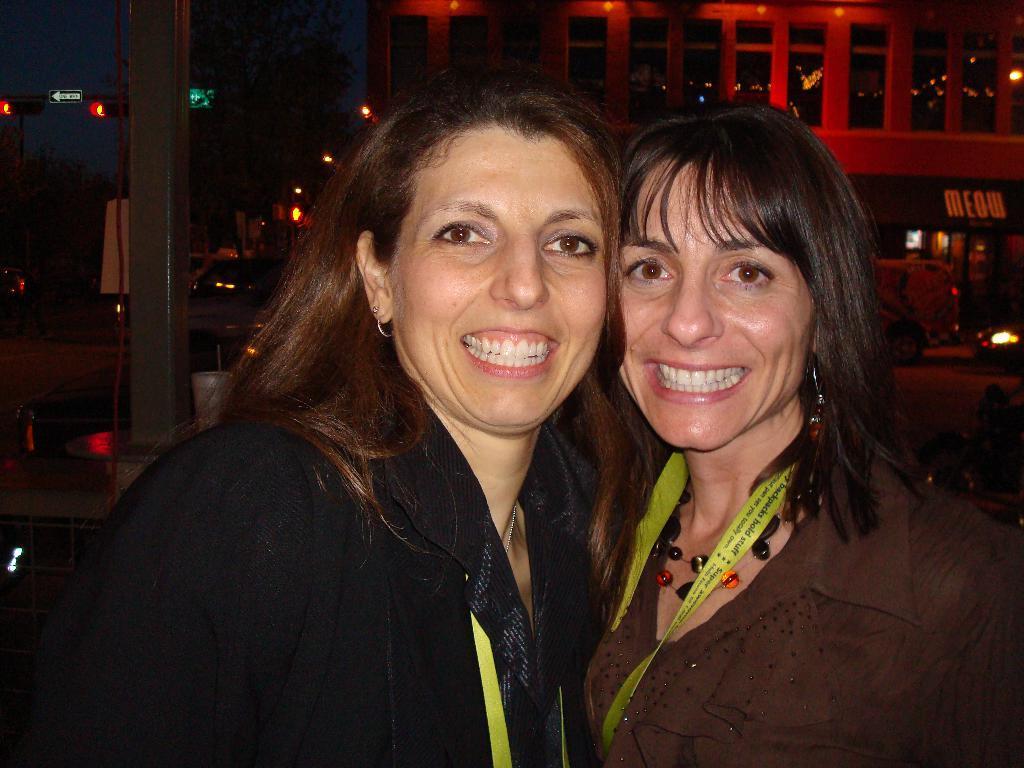Please provide a concise description of this image. In this image, we can see two women are watching and smiling. Background we can see building, trees, lights, banners, vehicles, road, poles, traffic signals, sign boards and few objects. 